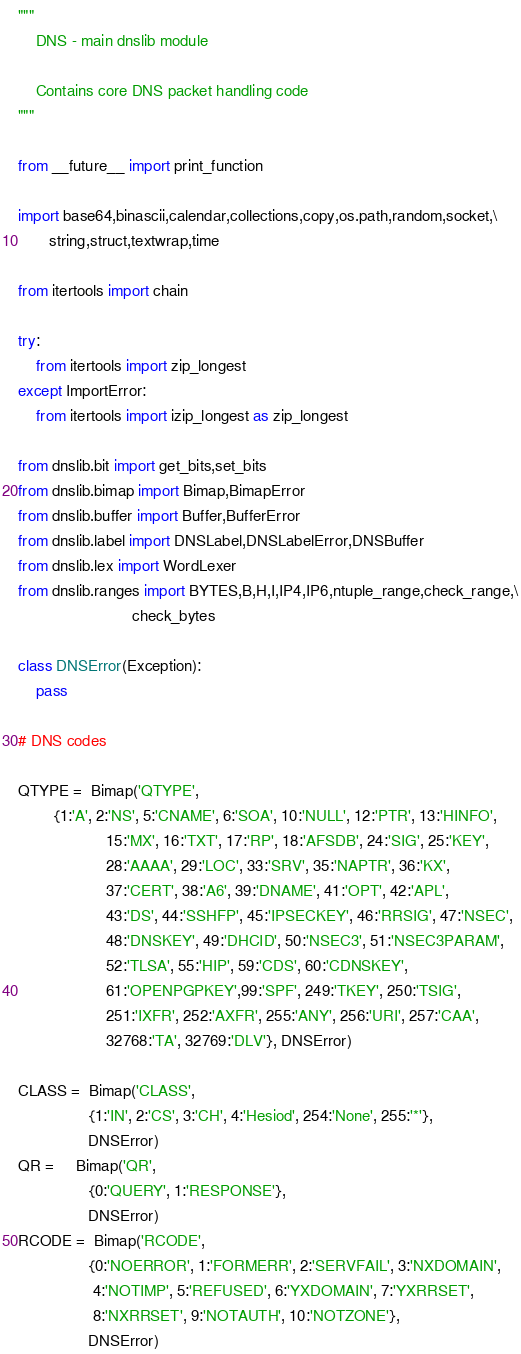<code> <loc_0><loc_0><loc_500><loc_500><_Python_>
"""
    DNS - main dnslib module

    Contains core DNS packet handling code
"""

from __future__ import print_function

import base64,binascii,calendar,collections,copy,os.path,random,socket,\
       string,struct,textwrap,time

from itertools import chain

try:
    from itertools import zip_longest
except ImportError:
    from itertools import izip_longest as zip_longest

from dnslib.bit import get_bits,set_bits
from dnslib.bimap import Bimap,BimapError
from dnslib.buffer import Buffer,BufferError
from dnslib.label import DNSLabel,DNSLabelError,DNSBuffer
from dnslib.lex import WordLexer
from dnslib.ranges import BYTES,B,H,I,IP4,IP6,ntuple_range,check_range,\
                          check_bytes

class DNSError(Exception):
    pass

# DNS codes

QTYPE =  Bimap('QTYPE',
        {1:'A', 2:'NS', 5:'CNAME', 6:'SOA', 10:'NULL', 12:'PTR', 13:'HINFO',
                    15:'MX', 16:'TXT', 17:'RP', 18:'AFSDB', 24:'SIG', 25:'KEY',
                    28:'AAAA', 29:'LOC', 33:'SRV', 35:'NAPTR', 36:'KX',
                    37:'CERT', 38:'A6', 39:'DNAME', 41:'OPT', 42:'APL',
                    43:'DS', 44:'SSHFP', 45:'IPSECKEY', 46:'RRSIG', 47:'NSEC',
                    48:'DNSKEY', 49:'DHCID', 50:'NSEC3', 51:'NSEC3PARAM',
                    52:'TLSA', 55:'HIP', 59:'CDS', 60:'CDNSKEY',
                    61:'OPENPGPKEY',99:'SPF', 249:'TKEY', 250:'TSIG',
                    251:'IXFR', 252:'AXFR', 255:'ANY', 256:'URI', 257:'CAA',
                    32768:'TA', 32769:'DLV'}, DNSError)

CLASS =  Bimap('CLASS',
                {1:'IN', 2:'CS', 3:'CH', 4:'Hesiod', 254:'None', 255:'*'},
                DNSError)
QR =     Bimap('QR',
                {0:'QUERY', 1:'RESPONSE'},
                DNSError)
RCODE =  Bimap('RCODE',
                {0:'NOERROR', 1:'FORMERR', 2:'SERVFAIL', 3:'NXDOMAIN',
                 4:'NOTIMP', 5:'REFUSED', 6:'YXDOMAIN', 7:'YXRRSET',
                 8:'NXRRSET', 9:'NOTAUTH', 10:'NOTZONE'},
                DNSError)</code> 